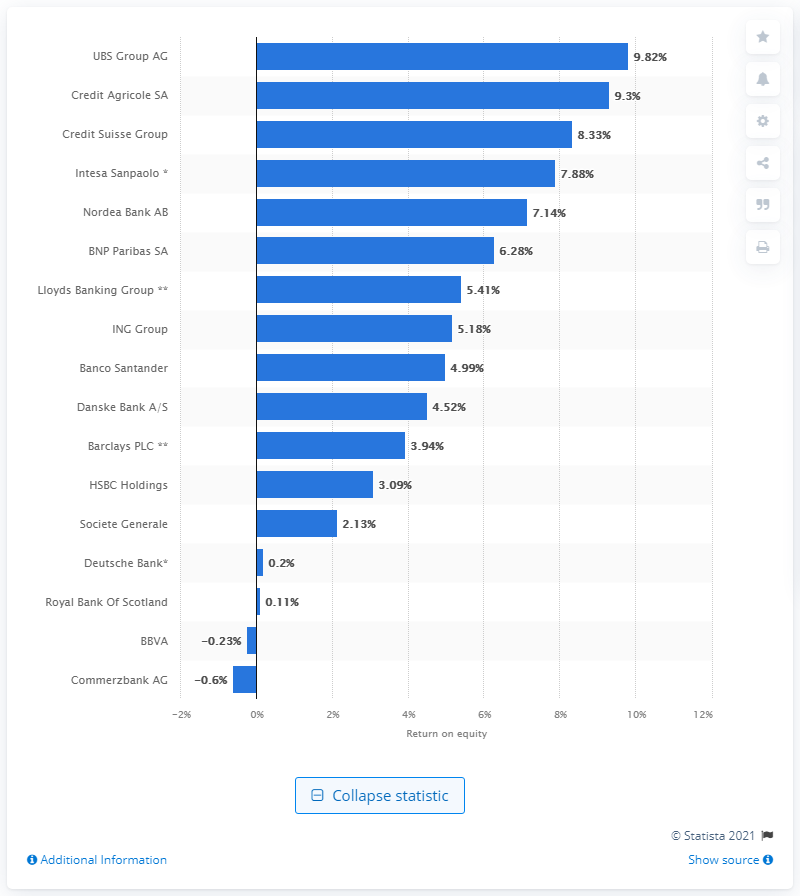Indicate a few pertinent items in this graphic. As of the third quarter of 2020, UBS Group AG was the European bank with the highest return on equity. Return on equity is a crucial indicator of a bank or country's banking sector's profitability. 